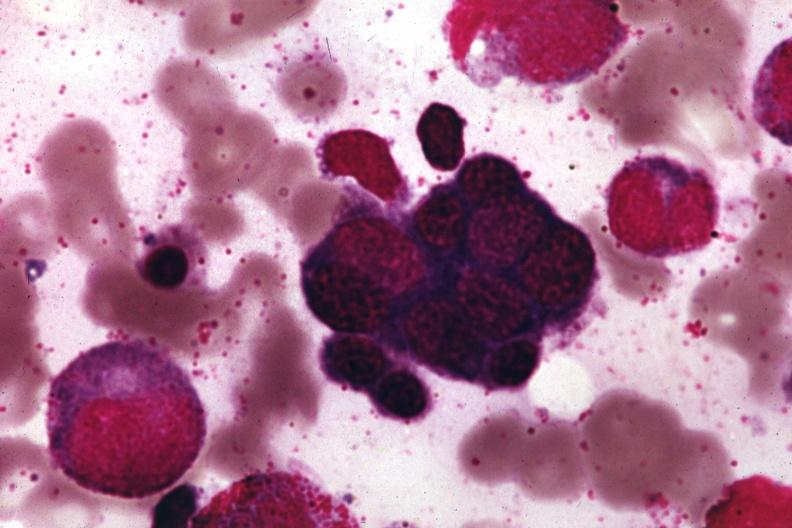s megaloblastic erythrocytes pernicious anemia present?
Answer the question using a single word or phrase. Yes 